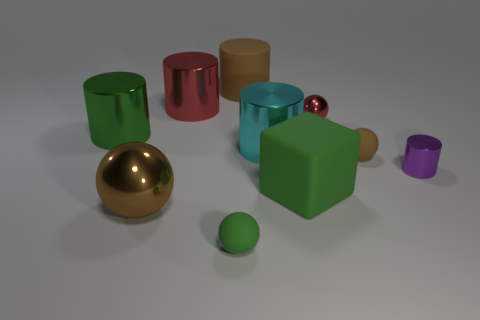How does the lighting in this scene affect our perception of the objects' colors? The lighting in the scene seems to be soft and diffused, casting gentle shadows and creating a naturalistic representation of the objects' colors. The subtle lighting helps to maintain the color integrity of each object, allowing us to perceive what might be their true colors under neutral lighting conditions without harsh highlights or deep shadows that could distort their appearance. 